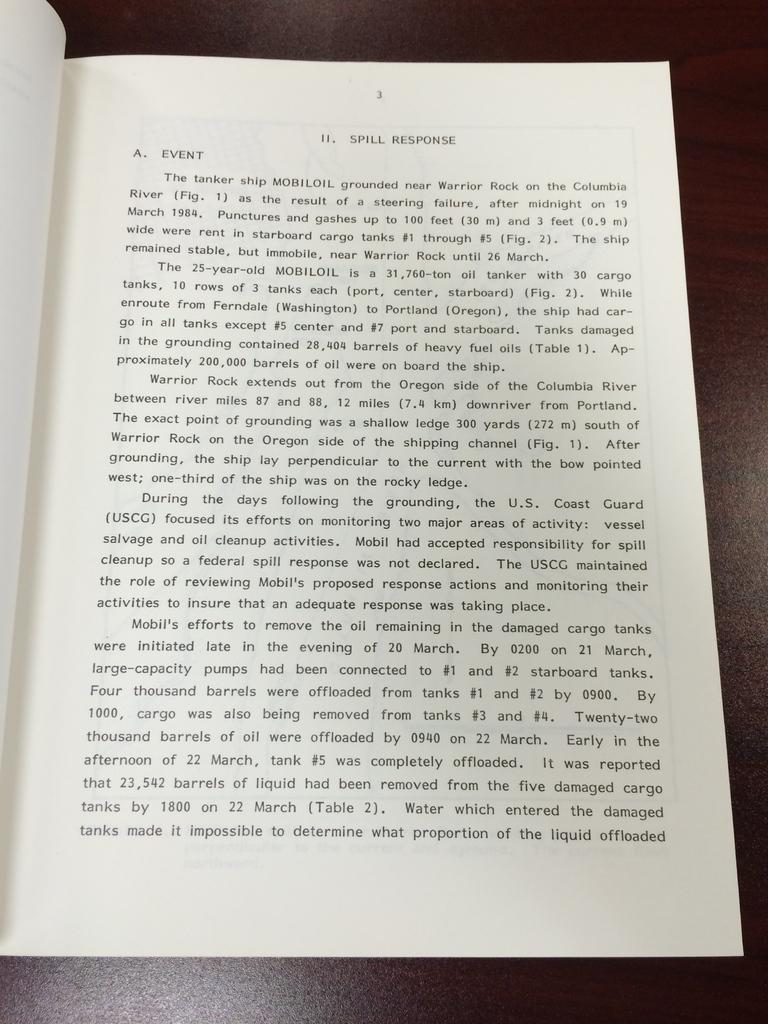What page is this book on?
Give a very brief answer. 3. What is the chapter name?
Make the answer very short. Spill response. 